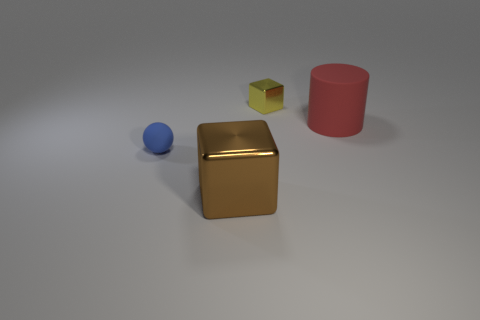What number of red rubber objects are the same size as the matte cylinder?
Your response must be concise. 0. What number of blue spheres are in front of the big cylinder?
Your response must be concise. 1. The thing that is to the left of the cube in front of the tiny blue object is made of what material?
Give a very brief answer. Rubber. Is there a metal object that has the same color as the large matte thing?
Your answer should be very brief. No. There is another block that is the same material as the large brown block; what is its size?
Offer a terse response. Small. Is there anything else that has the same color as the big block?
Offer a terse response. No. What color is the metallic cube to the left of the yellow metal cube?
Your answer should be compact. Brown. Are there any cylinders on the left side of the metallic cube that is in front of the large object on the right side of the tiny yellow thing?
Your answer should be compact. No. Is the number of brown cubes that are behind the small blue matte thing greater than the number of blue spheres?
Provide a short and direct response. No. Do the shiny thing that is on the left side of the tiny yellow cube and the big red thing have the same shape?
Make the answer very short. No. 